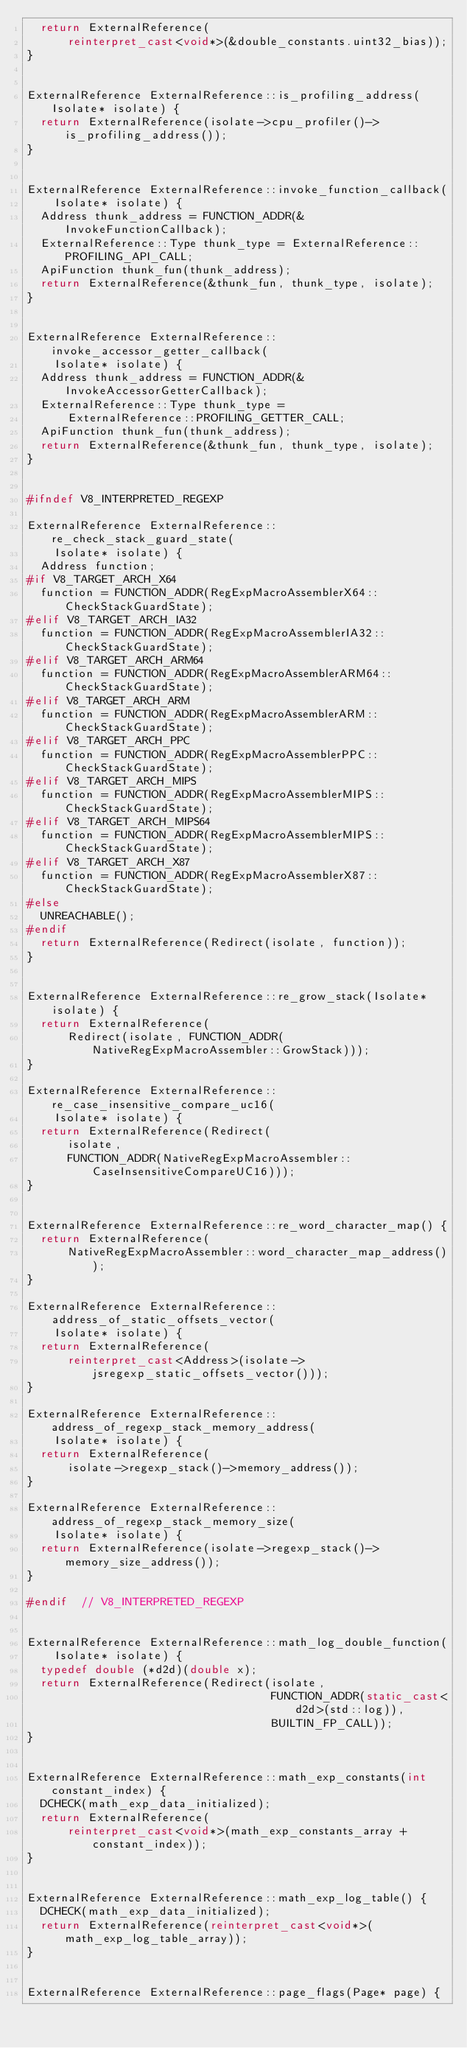Convert code to text. <code><loc_0><loc_0><loc_500><loc_500><_C++_>  return ExternalReference(
      reinterpret_cast<void*>(&double_constants.uint32_bias));
}


ExternalReference ExternalReference::is_profiling_address(Isolate* isolate) {
  return ExternalReference(isolate->cpu_profiler()->is_profiling_address());
}


ExternalReference ExternalReference::invoke_function_callback(
    Isolate* isolate) {
  Address thunk_address = FUNCTION_ADDR(&InvokeFunctionCallback);
  ExternalReference::Type thunk_type = ExternalReference::PROFILING_API_CALL;
  ApiFunction thunk_fun(thunk_address);
  return ExternalReference(&thunk_fun, thunk_type, isolate);
}


ExternalReference ExternalReference::invoke_accessor_getter_callback(
    Isolate* isolate) {
  Address thunk_address = FUNCTION_ADDR(&InvokeAccessorGetterCallback);
  ExternalReference::Type thunk_type =
      ExternalReference::PROFILING_GETTER_CALL;
  ApiFunction thunk_fun(thunk_address);
  return ExternalReference(&thunk_fun, thunk_type, isolate);
}


#ifndef V8_INTERPRETED_REGEXP

ExternalReference ExternalReference::re_check_stack_guard_state(
    Isolate* isolate) {
  Address function;
#if V8_TARGET_ARCH_X64
  function = FUNCTION_ADDR(RegExpMacroAssemblerX64::CheckStackGuardState);
#elif V8_TARGET_ARCH_IA32
  function = FUNCTION_ADDR(RegExpMacroAssemblerIA32::CheckStackGuardState);
#elif V8_TARGET_ARCH_ARM64
  function = FUNCTION_ADDR(RegExpMacroAssemblerARM64::CheckStackGuardState);
#elif V8_TARGET_ARCH_ARM
  function = FUNCTION_ADDR(RegExpMacroAssemblerARM::CheckStackGuardState);
#elif V8_TARGET_ARCH_PPC
  function = FUNCTION_ADDR(RegExpMacroAssemblerPPC::CheckStackGuardState);
#elif V8_TARGET_ARCH_MIPS
  function = FUNCTION_ADDR(RegExpMacroAssemblerMIPS::CheckStackGuardState);
#elif V8_TARGET_ARCH_MIPS64
  function = FUNCTION_ADDR(RegExpMacroAssemblerMIPS::CheckStackGuardState);
#elif V8_TARGET_ARCH_X87
  function = FUNCTION_ADDR(RegExpMacroAssemblerX87::CheckStackGuardState);
#else
  UNREACHABLE();
#endif
  return ExternalReference(Redirect(isolate, function));
}


ExternalReference ExternalReference::re_grow_stack(Isolate* isolate) {
  return ExternalReference(
      Redirect(isolate, FUNCTION_ADDR(NativeRegExpMacroAssembler::GrowStack)));
}

ExternalReference ExternalReference::re_case_insensitive_compare_uc16(
    Isolate* isolate) {
  return ExternalReference(Redirect(
      isolate,
      FUNCTION_ADDR(NativeRegExpMacroAssembler::CaseInsensitiveCompareUC16)));
}


ExternalReference ExternalReference::re_word_character_map() {
  return ExternalReference(
      NativeRegExpMacroAssembler::word_character_map_address());
}

ExternalReference ExternalReference::address_of_static_offsets_vector(
    Isolate* isolate) {
  return ExternalReference(
      reinterpret_cast<Address>(isolate->jsregexp_static_offsets_vector()));
}

ExternalReference ExternalReference::address_of_regexp_stack_memory_address(
    Isolate* isolate) {
  return ExternalReference(
      isolate->regexp_stack()->memory_address());
}

ExternalReference ExternalReference::address_of_regexp_stack_memory_size(
    Isolate* isolate) {
  return ExternalReference(isolate->regexp_stack()->memory_size_address());
}

#endif  // V8_INTERPRETED_REGEXP


ExternalReference ExternalReference::math_log_double_function(
    Isolate* isolate) {
  typedef double (*d2d)(double x);
  return ExternalReference(Redirect(isolate,
                                    FUNCTION_ADDR(static_cast<d2d>(std::log)),
                                    BUILTIN_FP_CALL));
}


ExternalReference ExternalReference::math_exp_constants(int constant_index) {
  DCHECK(math_exp_data_initialized);
  return ExternalReference(
      reinterpret_cast<void*>(math_exp_constants_array + constant_index));
}


ExternalReference ExternalReference::math_exp_log_table() {
  DCHECK(math_exp_data_initialized);
  return ExternalReference(reinterpret_cast<void*>(math_exp_log_table_array));
}


ExternalReference ExternalReference::page_flags(Page* page) {</code> 